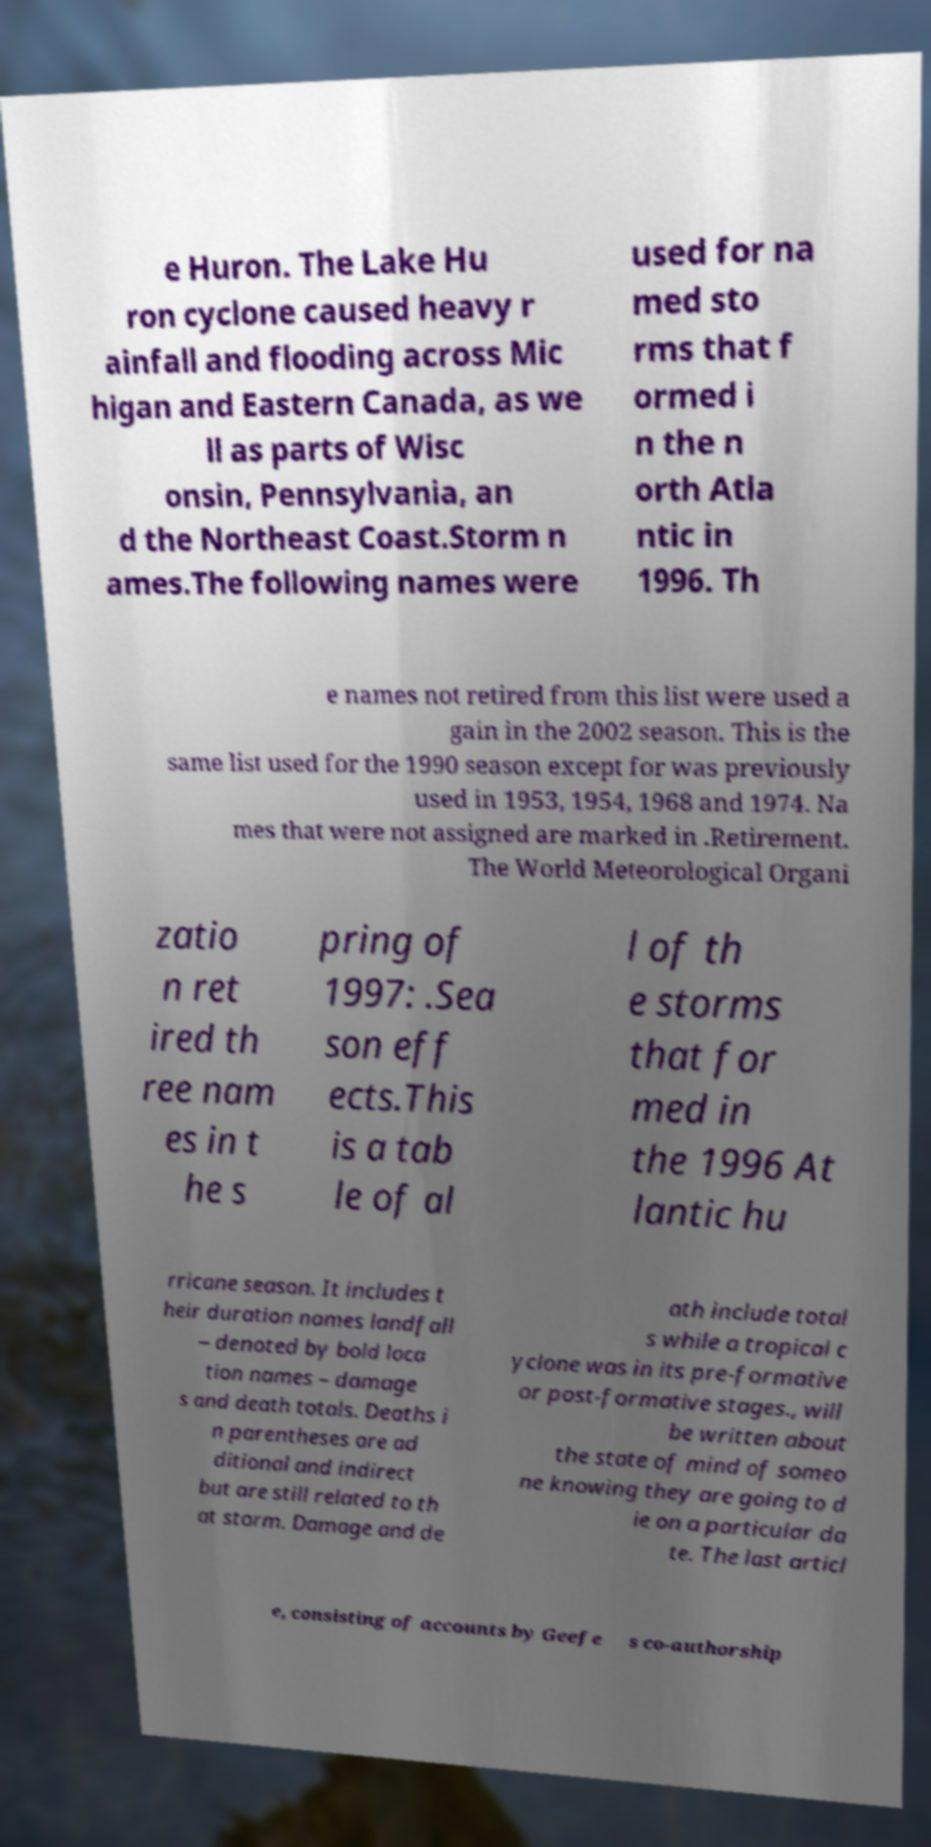Can you read and provide the text displayed in the image?This photo seems to have some interesting text. Can you extract and type it out for me? e Huron. The Lake Hu ron cyclone caused heavy r ainfall and flooding across Mic higan and Eastern Canada, as we ll as parts of Wisc onsin, Pennsylvania, an d the Northeast Coast.Storm n ames.The following names were used for na med sto rms that f ormed i n the n orth Atla ntic in 1996. Th e names not retired from this list were used a gain in the 2002 season. This is the same list used for the 1990 season except for was previously used in 1953, 1954, 1968 and 1974. Na mes that were not assigned are marked in .Retirement. The World Meteorological Organi zatio n ret ired th ree nam es in t he s pring of 1997: .Sea son eff ects.This is a tab le of al l of th e storms that for med in the 1996 At lantic hu rricane season. It includes t heir duration names landfall – denoted by bold loca tion names – damage s and death totals. Deaths i n parentheses are ad ditional and indirect but are still related to th at storm. Damage and de ath include total s while a tropical c yclone was in its pre-formative or post-formative stages., will be written about the state of mind of someo ne knowing they are going to d ie on a particular da te. The last articl e, consisting of accounts by Geefe s co-authorship 